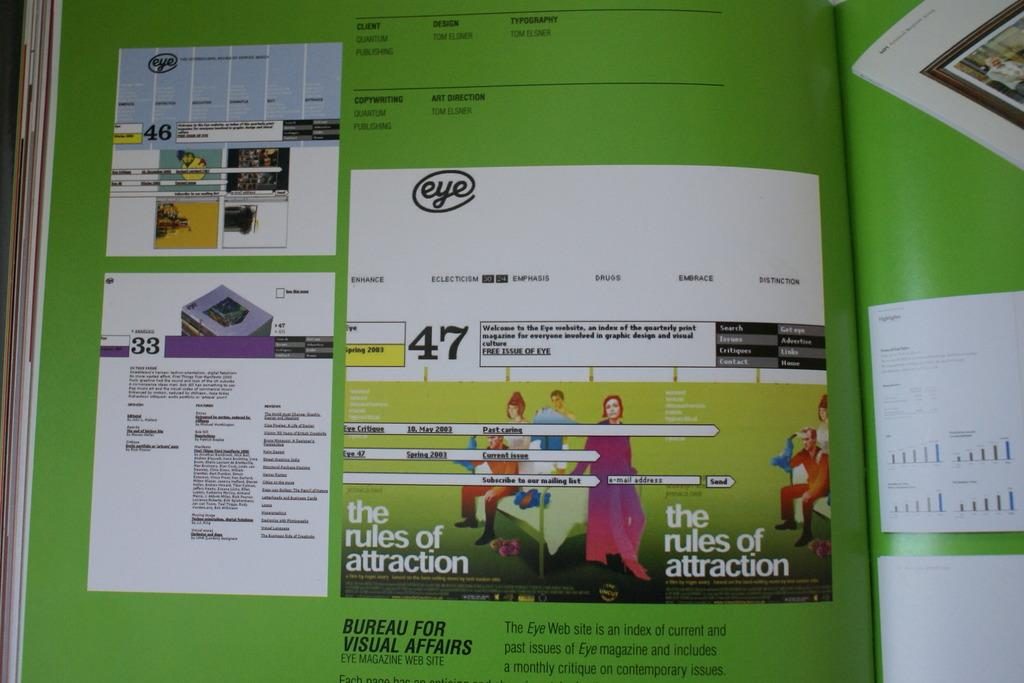Provide a one-sentence caption for the provided image. A magazine is opened to a page in green with test at the bottom that says "Bureau for Visual Affairs.". 